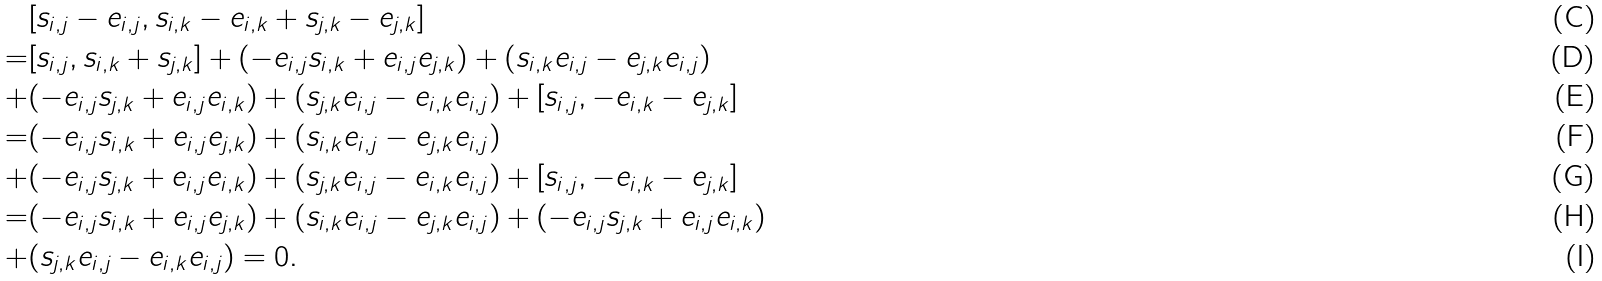Convert formula to latex. <formula><loc_0><loc_0><loc_500><loc_500>& [ s _ { i , j } - e _ { i , j } , s _ { i , k } - e _ { i , k } + s _ { j , k } - e _ { j , k } ] \\ = & [ s _ { i , j } , s _ { i , k } + s _ { j , k } ] + ( - e _ { i , j } s _ { i , k } + e _ { i , j } e _ { j , k } ) + ( s _ { i , k } e _ { i , j } - e _ { j , k } e _ { i , j } ) \\ + & ( - e _ { i , j } s _ { j , k } + e _ { i , j } e _ { i , k } ) + ( s _ { j , k } e _ { i , j } - e _ { i , k } e _ { i , j } ) + [ s _ { i , j } , - e _ { i , k } - e _ { j , k } ] \\ = & ( - e _ { i , j } s _ { i , k } + e _ { i , j } e _ { j , k } ) + ( s _ { i , k } e _ { i , j } - e _ { j , k } e _ { i , j } ) \\ + & ( - e _ { i , j } s _ { j , k } + e _ { i , j } e _ { i , k } ) + ( s _ { j , k } e _ { i , j } - e _ { i , k } e _ { i , j } ) + [ s _ { i , j } , - e _ { i , k } - e _ { j , k } ] \\ = & ( - e _ { i , j } s _ { i , k } + e _ { i , j } e _ { j , k } ) + ( s _ { i , k } e _ { i , j } - e _ { j , k } e _ { i , j } ) + ( - e _ { i , j } s _ { j , k } + e _ { i , j } e _ { i , k } ) \\ + & ( s _ { j , k } e _ { i , j } - e _ { i , k } e _ { i , j } ) = 0 .</formula> 